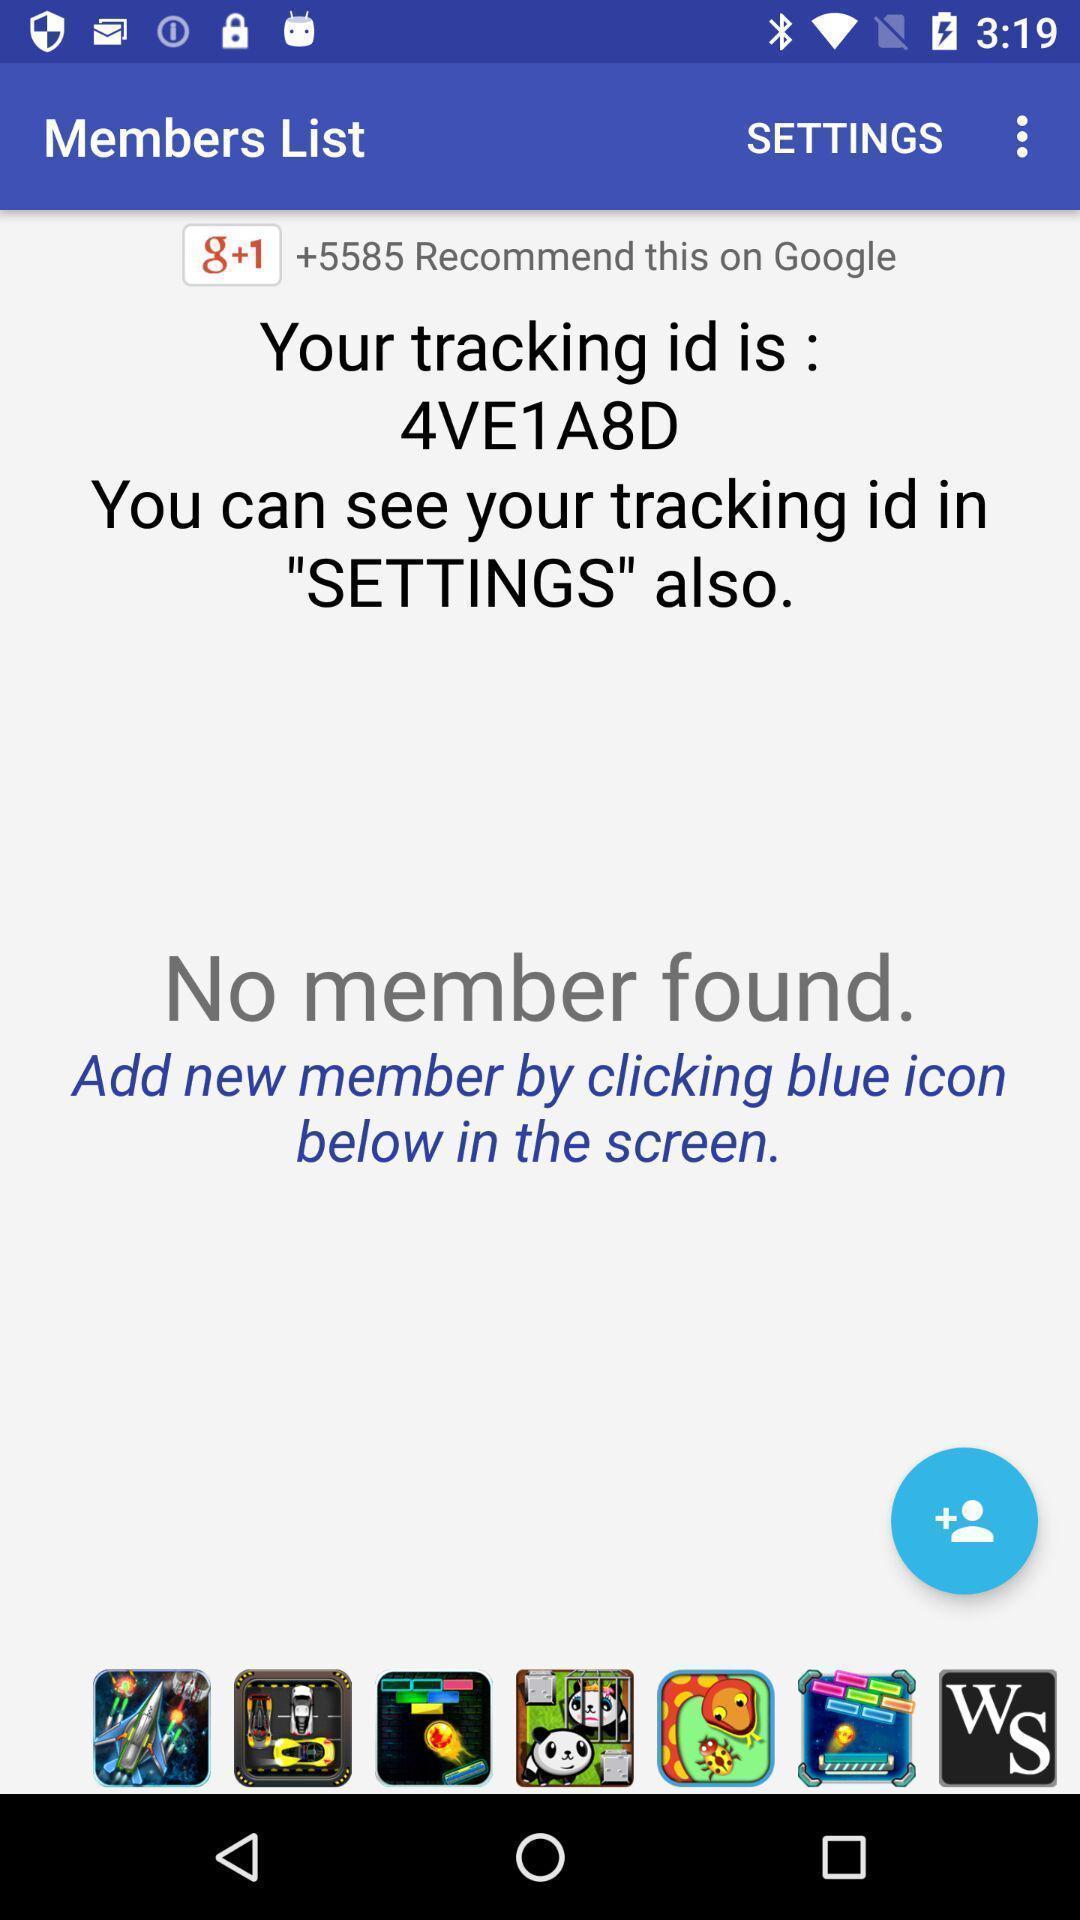What can you discern from this picture? Screen showing tracker id. 